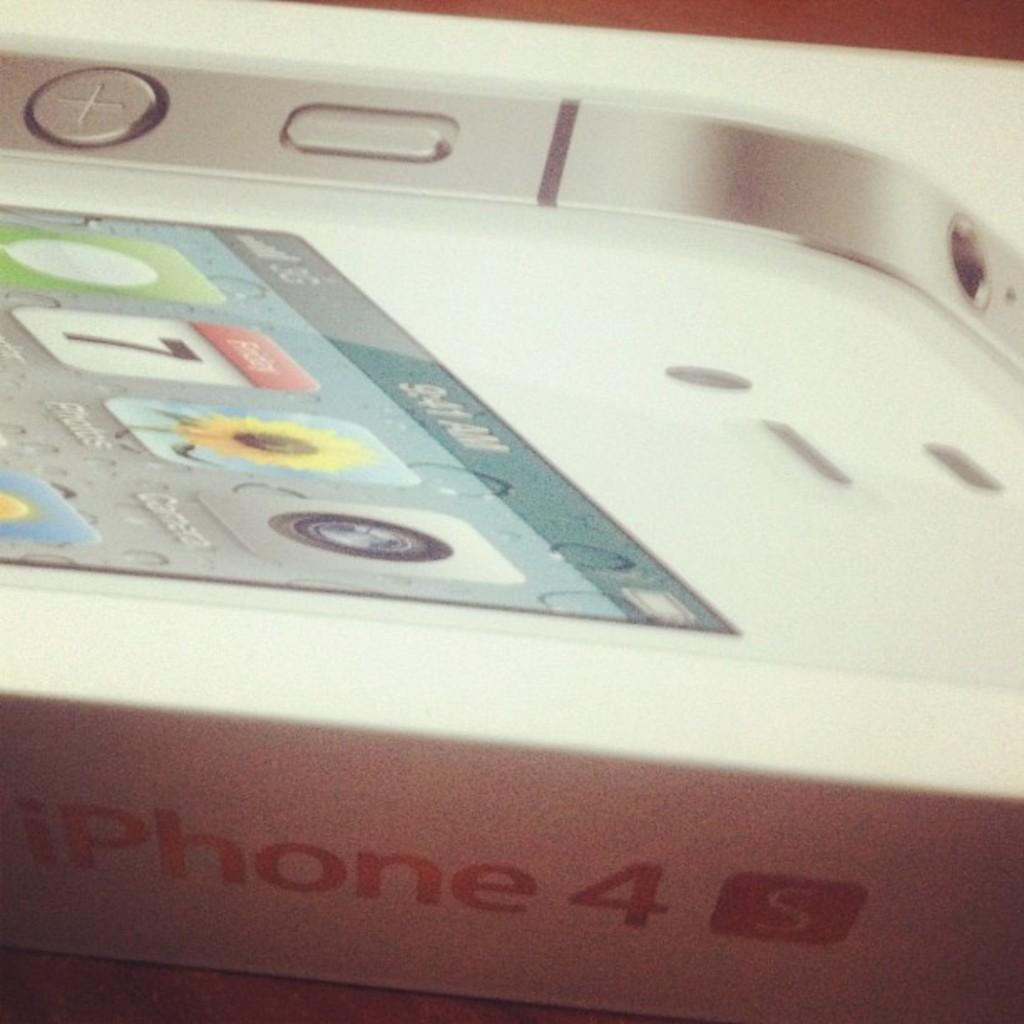<image>
Relay a brief, clear account of the picture shown. A white iPhone 4 is nestled in its box. 